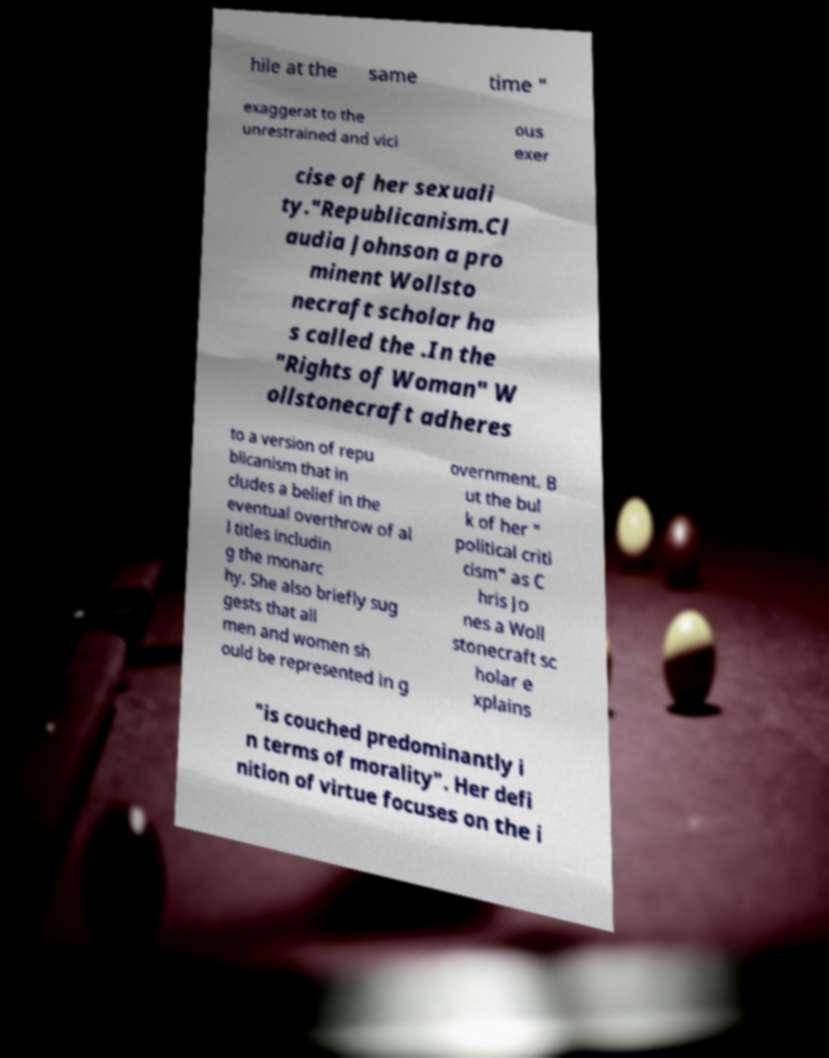For documentation purposes, I need the text within this image transcribed. Could you provide that? hile at the same time " exaggerat to the unrestrained and vici ous exer cise of her sexuali ty."Republicanism.Cl audia Johnson a pro minent Wollsto necraft scholar ha s called the .In the "Rights of Woman" W ollstonecraft adheres to a version of repu blicanism that in cludes a belief in the eventual overthrow of al l titles includin g the monarc hy. She also briefly sug gests that all men and women sh ould be represented in g overnment. B ut the bul k of her " political criti cism" as C hris Jo nes a Woll stonecraft sc holar e xplains "is couched predominantly i n terms of morality". Her defi nition of virtue focuses on the i 